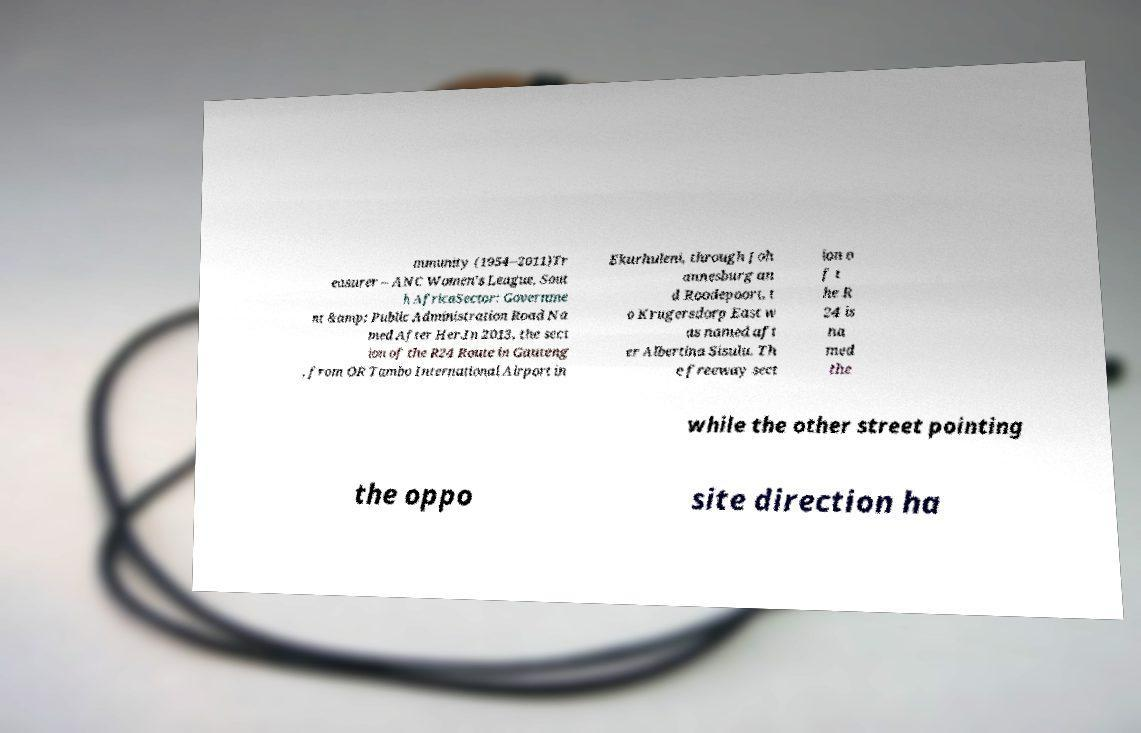There's text embedded in this image that I need extracted. Can you transcribe it verbatim? mmunity (1954–2011)Tr easurer – ANC Women's League, Sout h AfricaSector: Governme nt &amp; Public Administration Road Na med After Her.In 2013, the sect ion of the R24 Route in Gauteng , from OR Tambo International Airport in Ekurhuleni, through Joh annesburg an d Roodepoort, t o Krugersdorp East w as named aft er Albertina Sisulu. Th e freeway sect ion o f t he R 24 is na med the while the other street pointing the oppo site direction ha 